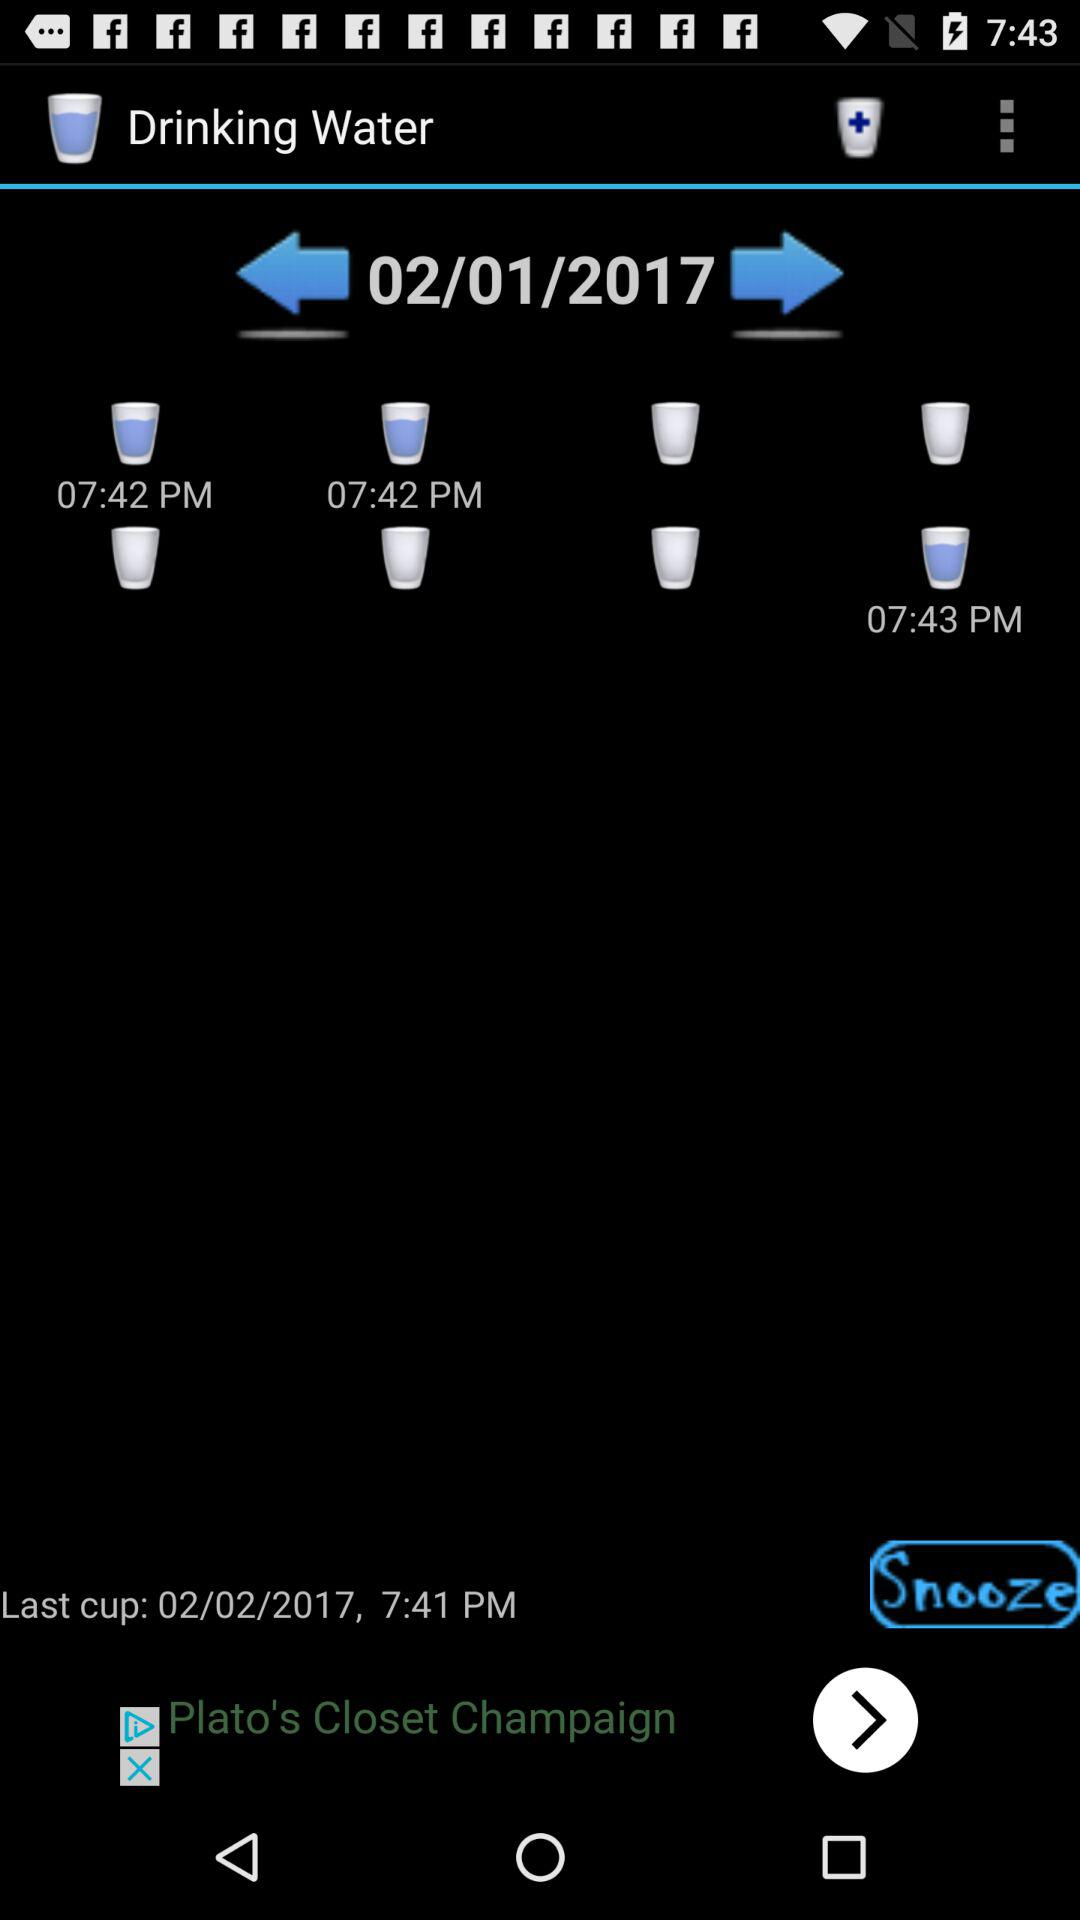How many cups of water have been consumed today?
Answer the question using a single word or phrase. 3 